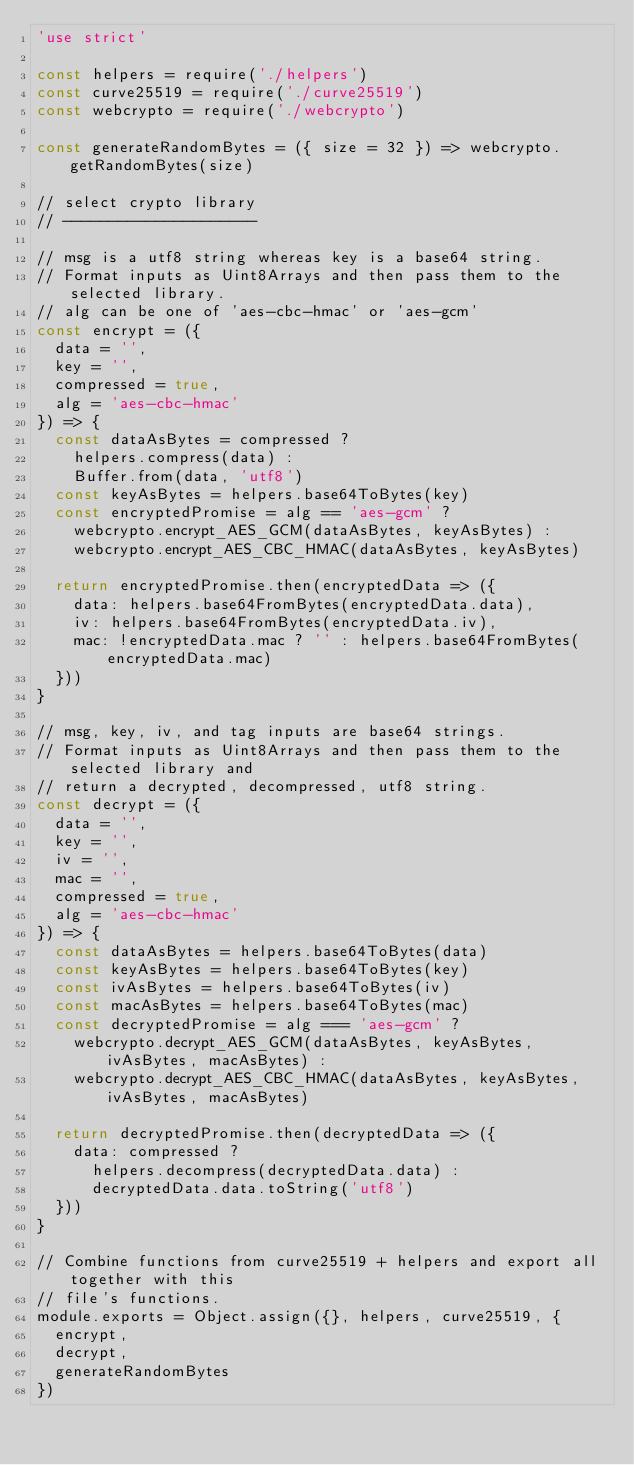<code> <loc_0><loc_0><loc_500><loc_500><_JavaScript_>'use strict'

const helpers = require('./helpers')
const curve25519 = require('./curve25519')
const webcrypto = require('./webcrypto')

const generateRandomBytes = ({ size = 32 }) => webcrypto.getRandomBytes(size)

// select crypto library
// ---------------------

// msg is a utf8 string whereas key is a base64 string.
// Format inputs as Uint8Arrays and then pass them to the selected library.
// alg can be one of 'aes-cbc-hmac' or 'aes-gcm'
const encrypt = ({
  data = '',
  key = '',
  compressed = true,
  alg = 'aes-cbc-hmac'
}) => {
  const dataAsBytes = compressed ?
    helpers.compress(data) :
    Buffer.from(data, 'utf8')
  const keyAsBytes = helpers.base64ToBytes(key)
  const encryptedPromise = alg == 'aes-gcm' ?
    webcrypto.encrypt_AES_GCM(dataAsBytes, keyAsBytes) :
    webcrypto.encrypt_AES_CBC_HMAC(dataAsBytes, keyAsBytes)

  return encryptedPromise.then(encryptedData => ({
    data: helpers.base64FromBytes(encryptedData.data),
    iv: helpers.base64FromBytes(encryptedData.iv),
    mac: !encryptedData.mac ? '' : helpers.base64FromBytes(encryptedData.mac)
  }))
}

// msg, key, iv, and tag inputs are base64 strings.
// Format inputs as Uint8Arrays and then pass them to the selected library and
// return a decrypted, decompressed, utf8 string.
const decrypt = ({
  data = '',
  key = '',
  iv = '',
  mac = '',
  compressed = true,
  alg = 'aes-cbc-hmac'
}) => {
  const dataAsBytes = helpers.base64ToBytes(data)
  const keyAsBytes = helpers.base64ToBytes(key)
  const ivAsBytes = helpers.base64ToBytes(iv)
  const macAsBytes = helpers.base64ToBytes(mac)
  const decryptedPromise = alg === 'aes-gcm' ?
    webcrypto.decrypt_AES_GCM(dataAsBytes, keyAsBytes, ivAsBytes, macAsBytes) :
    webcrypto.decrypt_AES_CBC_HMAC(dataAsBytes, keyAsBytes, ivAsBytes, macAsBytes)

  return decryptedPromise.then(decryptedData => ({
    data: compressed ?
      helpers.decompress(decryptedData.data) :
      decryptedData.data.toString('utf8')
  }))
}

// Combine functions from curve25519 + helpers and export all together with this
// file's functions.
module.exports = Object.assign({}, helpers, curve25519, {
  encrypt,
  decrypt,
  generateRandomBytes
})
</code> 